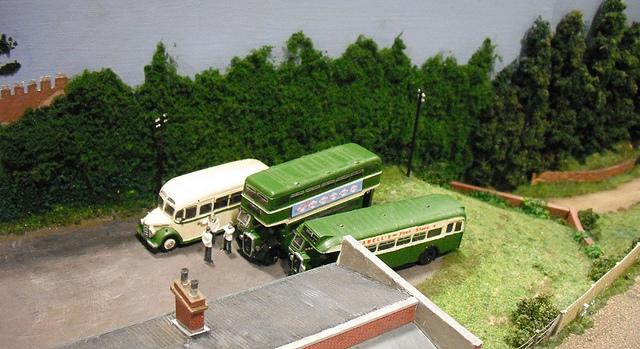Is this on a city street?
Quick response, please. No. How many buses?
Write a very short answer. 3. Do you think this shot was taken from a helicopter?
Quick response, please. Yes. What color is the top of the lamp post in the bottom left of the photo?
Write a very short answer. Black. 